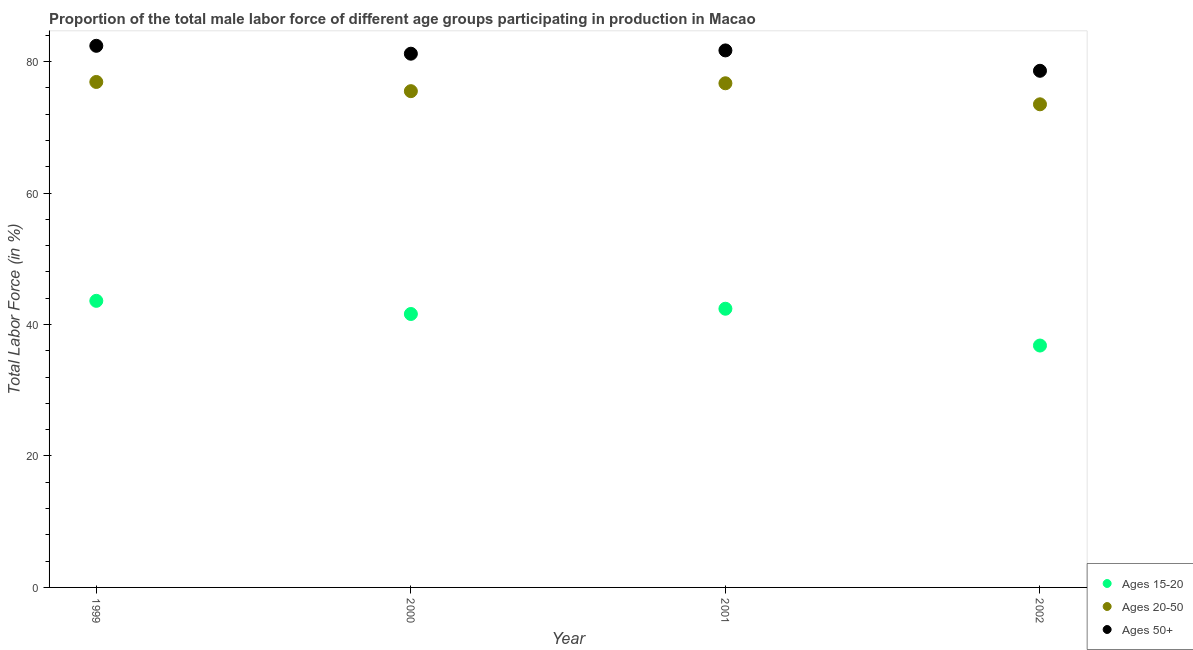What is the percentage of male labor force within the age group 15-20 in 1999?
Offer a very short reply. 43.6. Across all years, what is the maximum percentage of male labor force above age 50?
Provide a short and direct response. 82.4. Across all years, what is the minimum percentage of male labor force within the age group 20-50?
Offer a very short reply. 73.5. In which year was the percentage of male labor force above age 50 maximum?
Ensure brevity in your answer.  1999. What is the total percentage of male labor force within the age group 20-50 in the graph?
Your answer should be very brief. 302.6. What is the difference between the percentage of male labor force above age 50 in 1999 and that in 2002?
Ensure brevity in your answer.  3.8. What is the difference between the percentage of male labor force above age 50 in 1999 and the percentage of male labor force within the age group 15-20 in 2002?
Offer a terse response. 45.6. What is the average percentage of male labor force within the age group 20-50 per year?
Provide a succinct answer. 75.65. In the year 1999, what is the difference between the percentage of male labor force within the age group 15-20 and percentage of male labor force above age 50?
Provide a short and direct response. -38.8. In how many years, is the percentage of male labor force within the age group 15-20 greater than 4 %?
Provide a short and direct response. 4. What is the ratio of the percentage of male labor force above age 50 in 1999 to that in 2001?
Your answer should be very brief. 1.01. What is the difference between the highest and the second highest percentage of male labor force above age 50?
Your answer should be very brief. 0.7. What is the difference between the highest and the lowest percentage of male labor force above age 50?
Ensure brevity in your answer.  3.8. Is the percentage of male labor force above age 50 strictly less than the percentage of male labor force within the age group 15-20 over the years?
Give a very brief answer. No. How many years are there in the graph?
Give a very brief answer. 4. What is the difference between two consecutive major ticks on the Y-axis?
Provide a short and direct response. 20. Does the graph contain grids?
Your answer should be compact. No. How many legend labels are there?
Provide a succinct answer. 3. What is the title of the graph?
Ensure brevity in your answer.  Proportion of the total male labor force of different age groups participating in production in Macao. What is the Total Labor Force (in %) of Ages 15-20 in 1999?
Offer a terse response. 43.6. What is the Total Labor Force (in %) of Ages 20-50 in 1999?
Provide a succinct answer. 76.9. What is the Total Labor Force (in %) of Ages 50+ in 1999?
Your answer should be compact. 82.4. What is the Total Labor Force (in %) in Ages 15-20 in 2000?
Provide a succinct answer. 41.6. What is the Total Labor Force (in %) in Ages 20-50 in 2000?
Provide a short and direct response. 75.5. What is the Total Labor Force (in %) in Ages 50+ in 2000?
Offer a terse response. 81.2. What is the Total Labor Force (in %) in Ages 15-20 in 2001?
Keep it short and to the point. 42.4. What is the Total Labor Force (in %) in Ages 20-50 in 2001?
Ensure brevity in your answer.  76.7. What is the Total Labor Force (in %) in Ages 50+ in 2001?
Your response must be concise. 81.7. What is the Total Labor Force (in %) of Ages 15-20 in 2002?
Your response must be concise. 36.8. What is the Total Labor Force (in %) of Ages 20-50 in 2002?
Provide a succinct answer. 73.5. What is the Total Labor Force (in %) of Ages 50+ in 2002?
Your answer should be compact. 78.6. Across all years, what is the maximum Total Labor Force (in %) in Ages 15-20?
Provide a succinct answer. 43.6. Across all years, what is the maximum Total Labor Force (in %) in Ages 20-50?
Provide a succinct answer. 76.9. Across all years, what is the maximum Total Labor Force (in %) of Ages 50+?
Your response must be concise. 82.4. Across all years, what is the minimum Total Labor Force (in %) in Ages 15-20?
Your response must be concise. 36.8. Across all years, what is the minimum Total Labor Force (in %) of Ages 20-50?
Keep it short and to the point. 73.5. Across all years, what is the minimum Total Labor Force (in %) of Ages 50+?
Your answer should be very brief. 78.6. What is the total Total Labor Force (in %) of Ages 15-20 in the graph?
Keep it short and to the point. 164.4. What is the total Total Labor Force (in %) in Ages 20-50 in the graph?
Offer a very short reply. 302.6. What is the total Total Labor Force (in %) in Ages 50+ in the graph?
Your response must be concise. 323.9. What is the difference between the Total Labor Force (in %) of Ages 50+ in 1999 and that in 2000?
Your answer should be compact. 1.2. What is the difference between the Total Labor Force (in %) of Ages 15-20 in 1999 and that in 2001?
Offer a very short reply. 1.2. What is the difference between the Total Labor Force (in %) of Ages 20-50 in 1999 and that in 2001?
Give a very brief answer. 0.2. What is the difference between the Total Labor Force (in %) in Ages 50+ in 1999 and that in 2001?
Offer a very short reply. 0.7. What is the difference between the Total Labor Force (in %) in Ages 50+ in 1999 and that in 2002?
Keep it short and to the point. 3.8. What is the difference between the Total Labor Force (in %) in Ages 20-50 in 2000 and that in 2001?
Give a very brief answer. -1.2. What is the difference between the Total Labor Force (in %) in Ages 50+ in 2000 and that in 2001?
Keep it short and to the point. -0.5. What is the difference between the Total Labor Force (in %) in Ages 15-20 in 2000 and that in 2002?
Your response must be concise. 4.8. What is the difference between the Total Labor Force (in %) in Ages 20-50 in 2000 and that in 2002?
Offer a very short reply. 2. What is the difference between the Total Labor Force (in %) of Ages 50+ in 2000 and that in 2002?
Provide a short and direct response. 2.6. What is the difference between the Total Labor Force (in %) in Ages 15-20 in 1999 and the Total Labor Force (in %) in Ages 20-50 in 2000?
Provide a short and direct response. -31.9. What is the difference between the Total Labor Force (in %) of Ages 15-20 in 1999 and the Total Labor Force (in %) of Ages 50+ in 2000?
Offer a terse response. -37.6. What is the difference between the Total Labor Force (in %) of Ages 15-20 in 1999 and the Total Labor Force (in %) of Ages 20-50 in 2001?
Give a very brief answer. -33.1. What is the difference between the Total Labor Force (in %) of Ages 15-20 in 1999 and the Total Labor Force (in %) of Ages 50+ in 2001?
Your response must be concise. -38.1. What is the difference between the Total Labor Force (in %) in Ages 15-20 in 1999 and the Total Labor Force (in %) in Ages 20-50 in 2002?
Provide a succinct answer. -29.9. What is the difference between the Total Labor Force (in %) of Ages 15-20 in 1999 and the Total Labor Force (in %) of Ages 50+ in 2002?
Offer a very short reply. -35. What is the difference between the Total Labor Force (in %) of Ages 15-20 in 2000 and the Total Labor Force (in %) of Ages 20-50 in 2001?
Your answer should be compact. -35.1. What is the difference between the Total Labor Force (in %) in Ages 15-20 in 2000 and the Total Labor Force (in %) in Ages 50+ in 2001?
Your response must be concise. -40.1. What is the difference between the Total Labor Force (in %) in Ages 20-50 in 2000 and the Total Labor Force (in %) in Ages 50+ in 2001?
Keep it short and to the point. -6.2. What is the difference between the Total Labor Force (in %) of Ages 15-20 in 2000 and the Total Labor Force (in %) of Ages 20-50 in 2002?
Provide a succinct answer. -31.9. What is the difference between the Total Labor Force (in %) in Ages 15-20 in 2000 and the Total Labor Force (in %) in Ages 50+ in 2002?
Your response must be concise. -37. What is the difference between the Total Labor Force (in %) in Ages 20-50 in 2000 and the Total Labor Force (in %) in Ages 50+ in 2002?
Your answer should be compact. -3.1. What is the difference between the Total Labor Force (in %) in Ages 15-20 in 2001 and the Total Labor Force (in %) in Ages 20-50 in 2002?
Offer a very short reply. -31.1. What is the difference between the Total Labor Force (in %) in Ages 15-20 in 2001 and the Total Labor Force (in %) in Ages 50+ in 2002?
Provide a short and direct response. -36.2. What is the difference between the Total Labor Force (in %) in Ages 20-50 in 2001 and the Total Labor Force (in %) in Ages 50+ in 2002?
Offer a terse response. -1.9. What is the average Total Labor Force (in %) of Ages 15-20 per year?
Make the answer very short. 41.1. What is the average Total Labor Force (in %) of Ages 20-50 per year?
Offer a very short reply. 75.65. What is the average Total Labor Force (in %) in Ages 50+ per year?
Keep it short and to the point. 80.97. In the year 1999, what is the difference between the Total Labor Force (in %) in Ages 15-20 and Total Labor Force (in %) in Ages 20-50?
Ensure brevity in your answer.  -33.3. In the year 1999, what is the difference between the Total Labor Force (in %) of Ages 15-20 and Total Labor Force (in %) of Ages 50+?
Provide a succinct answer. -38.8. In the year 2000, what is the difference between the Total Labor Force (in %) in Ages 15-20 and Total Labor Force (in %) in Ages 20-50?
Ensure brevity in your answer.  -33.9. In the year 2000, what is the difference between the Total Labor Force (in %) in Ages 15-20 and Total Labor Force (in %) in Ages 50+?
Offer a very short reply. -39.6. In the year 2000, what is the difference between the Total Labor Force (in %) of Ages 20-50 and Total Labor Force (in %) of Ages 50+?
Your response must be concise. -5.7. In the year 2001, what is the difference between the Total Labor Force (in %) in Ages 15-20 and Total Labor Force (in %) in Ages 20-50?
Offer a very short reply. -34.3. In the year 2001, what is the difference between the Total Labor Force (in %) of Ages 15-20 and Total Labor Force (in %) of Ages 50+?
Give a very brief answer. -39.3. In the year 2002, what is the difference between the Total Labor Force (in %) of Ages 15-20 and Total Labor Force (in %) of Ages 20-50?
Offer a very short reply. -36.7. In the year 2002, what is the difference between the Total Labor Force (in %) in Ages 15-20 and Total Labor Force (in %) in Ages 50+?
Offer a terse response. -41.8. What is the ratio of the Total Labor Force (in %) in Ages 15-20 in 1999 to that in 2000?
Provide a succinct answer. 1.05. What is the ratio of the Total Labor Force (in %) in Ages 20-50 in 1999 to that in 2000?
Provide a succinct answer. 1.02. What is the ratio of the Total Labor Force (in %) of Ages 50+ in 1999 to that in 2000?
Make the answer very short. 1.01. What is the ratio of the Total Labor Force (in %) in Ages 15-20 in 1999 to that in 2001?
Provide a succinct answer. 1.03. What is the ratio of the Total Labor Force (in %) in Ages 20-50 in 1999 to that in 2001?
Offer a very short reply. 1. What is the ratio of the Total Labor Force (in %) in Ages 50+ in 1999 to that in 2001?
Keep it short and to the point. 1.01. What is the ratio of the Total Labor Force (in %) in Ages 15-20 in 1999 to that in 2002?
Your answer should be very brief. 1.18. What is the ratio of the Total Labor Force (in %) of Ages 20-50 in 1999 to that in 2002?
Keep it short and to the point. 1.05. What is the ratio of the Total Labor Force (in %) of Ages 50+ in 1999 to that in 2002?
Ensure brevity in your answer.  1.05. What is the ratio of the Total Labor Force (in %) in Ages 15-20 in 2000 to that in 2001?
Offer a very short reply. 0.98. What is the ratio of the Total Labor Force (in %) of Ages 20-50 in 2000 to that in 2001?
Give a very brief answer. 0.98. What is the ratio of the Total Labor Force (in %) in Ages 15-20 in 2000 to that in 2002?
Give a very brief answer. 1.13. What is the ratio of the Total Labor Force (in %) of Ages 20-50 in 2000 to that in 2002?
Your answer should be very brief. 1.03. What is the ratio of the Total Labor Force (in %) of Ages 50+ in 2000 to that in 2002?
Your answer should be very brief. 1.03. What is the ratio of the Total Labor Force (in %) of Ages 15-20 in 2001 to that in 2002?
Keep it short and to the point. 1.15. What is the ratio of the Total Labor Force (in %) of Ages 20-50 in 2001 to that in 2002?
Your answer should be very brief. 1.04. What is the ratio of the Total Labor Force (in %) of Ages 50+ in 2001 to that in 2002?
Your answer should be very brief. 1.04. What is the difference between the highest and the second highest Total Labor Force (in %) in Ages 20-50?
Offer a very short reply. 0.2. What is the difference between the highest and the second highest Total Labor Force (in %) in Ages 50+?
Keep it short and to the point. 0.7. What is the difference between the highest and the lowest Total Labor Force (in %) in Ages 50+?
Provide a succinct answer. 3.8. 